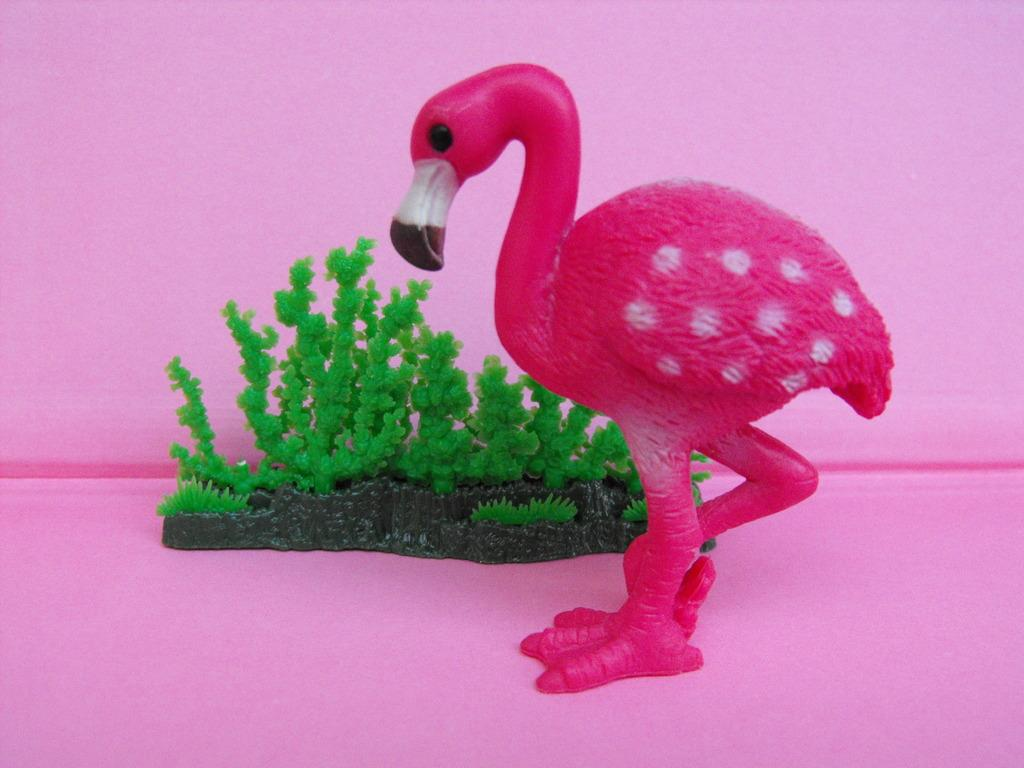What type of toy is present in the image? There is a toy duck and a toy plant in the image. What color is the surface in the image? The surface in the image is pink. What color is the background in the image? The background of the image is pink. What type of lamp can be seen in the image? There is no lamp present in the image. What is the reaction of the toy duck when the toy plant is watered? The image does not show any interaction between the toy duck and the toy plant, so it is not possible to determine their reaction. 